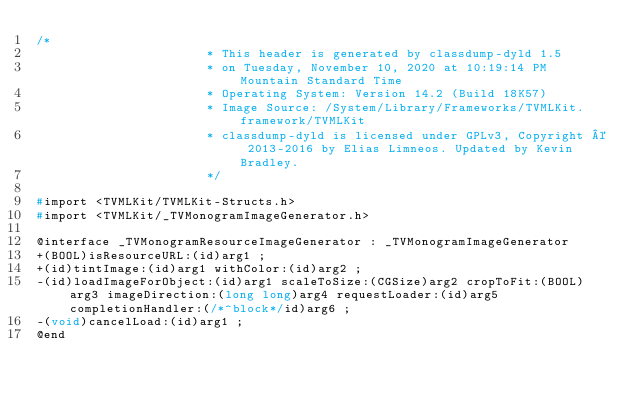<code> <loc_0><loc_0><loc_500><loc_500><_C_>/*
                       * This header is generated by classdump-dyld 1.5
                       * on Tuesday, November 10, 2020 at 10:19:14 PM Mountain Standard Time
                       * Operating System: Version 14.2 (Build 18K57)
                       * Image Source: /System/Library/Frameworks/TVMLKit.framework/TVMLKit
                       * classdump-dyld is licensed under GPLv3, Copyright © 2013-2016 by Elias Limneos. Updated by Kevin Bradley.
                       */

#import <TVMLKit/TVMLKit-Structs.h>
#import <TVMLKit/_TVMonogramImageGenerator.h>

@interface _TVMonogramResourceImageGenerator : _TVMonogramImageGenerator
+(BOOL)isResourceURL:(id)arg1 ;
+(id)tintImage:(id)arg1 withColor:(id)arg2 ;
-(id)loadImageForObject:(id)arg1 scaleToSize:(CGSize)arg2 cropToFit:(BOOL)arg3 imageDirection:(long long)arg4 requestLoader:(id)arg5 completionHandler:(/*^block*/id)arg6 ;
-(void)cancelLoad:(id)arg1 ;
@end

</code> 